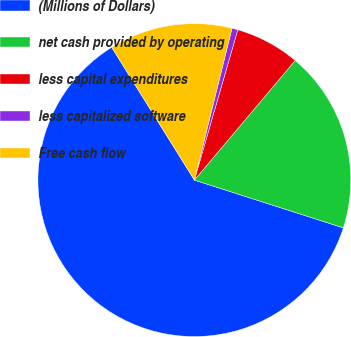<chart> <loc_0><loc_0><loc_500><loc_500><pie_chart><fcel>(Millions of Dollars)<fcel>net cash provided by operating<fcel>less capital expenditures<fcel>less capitalized software<fcel>Free cash flow<nl><fcel>61.2%<fcel>18.79%<fcel>6.67%<fcel>0.61%<fcel>12.73%<nl></chart> 